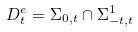Convert formula to latex. <formula><loc_0><loc_0><loc_500><loc_500>D _ { t } ^ { e } = \Sigma _ { 0 , t } \cap \Sigma _ { - t , t } ^ { 1 }</formula> 